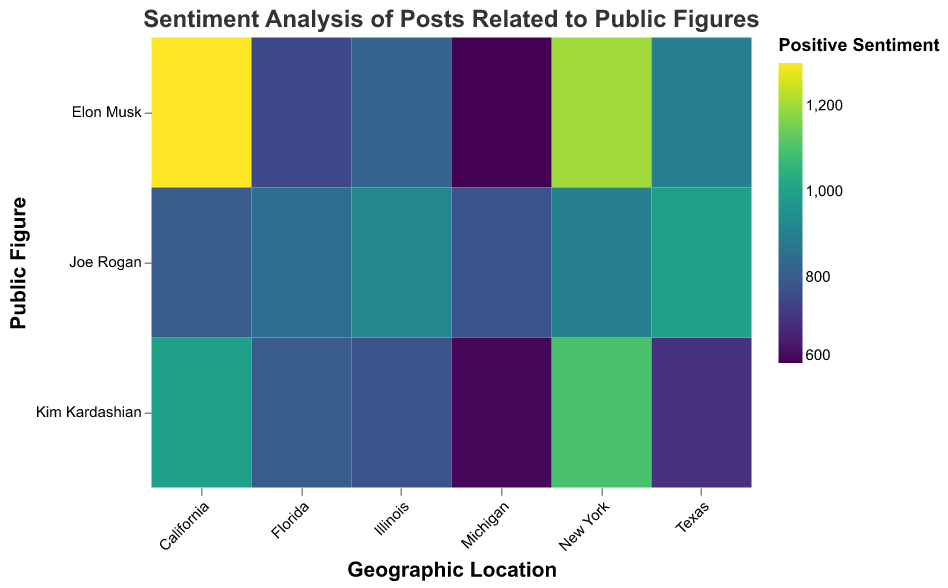What's the title of the figure? The title is displayed on top of the figure, usually in a larger and bold font, and it summarizes the main topic of the figure. The title here is "Sentiment Analysis of Posts Related to Public Figures".
Answer: Sentiment Analysis of Posts Related to Public Figures Which geographic location has the highest positive sentiment for Elon Musk? To find the geographic location with the highest positive sentiment for Elon Musk, look at the color representing positive sentiment for Elon Musk across all geographic locations. The darkest shade representing a higher number is in California.
Answer: California What are the sentiments (positive, neutral, negative) for Joe Rogan in Florida? Look at the tooltip or the specific cell in the heatmap where the geographic location is Florida, and the public figure is Joe Rogan. The values shown are 850 (positive), 680 (neutral), and 470 (negative).
Answer: Positive: 850, Neutral: 680, Negative: 470 Compare the positive sentiments for Kim Kardashian in Texas and Illinois. Which is higher? Locate the cells for Kim Kardashian in Texas and Illinois, then compare the color shades or tooltip numbers for positive sentiment. Texas has a positive sentiment of 700, while Illinois has 780. Illinois has the higher positive sentiment.
Answer: Illinois What's the average positive sentiment for Elon Musk across all geographic locations? Sum the positive sentiments for Elon Musk across all locations (1200 + 1300 + 900 + 750 + 820 + 600) and divide by the number of locations (6). The sum is 5570, so the average is 5570 / 6 = 928.33.
Answer: 928.33 In which state does Joe Rogan have the highest negative sentiment? Look for Joe Rogan's negative sentiment values in each geographic location and identify the highest value, which is 1200 in California.
Answer: California How does the neutral sentiment for Kim Kardashian in New York compare to that in Michigan? Find the neutral sentiment values for Kim Kardashian in New York (500) and Michigan (450). Comparing the two, New York has a higher neutral sentiment.
Answer: New York Which public figure has the lowest positive sentiment in Michigan? Look at the positive sentiment values for each public figure in Michigan and identify the lowest value. Elon Musk has the lowest positive sentiment at 600.
Answer: Elon Musk What is the total number of positive sentiments for Joe Rogan across all geographic locations? Add the positive sentiment values for Joe Rogan across all locations (900 + 800 + 1000 + 850 + 920 + 780). The sum is 5250.
Answer: 5250 What's the difference in negative sentiment for Elon Musk between New York and Texas? Subtract the negative sentiment for Elon Musk in Texas (800) from that in New York (600). The difference is 600 - 800 = -200.
Answer: -200 